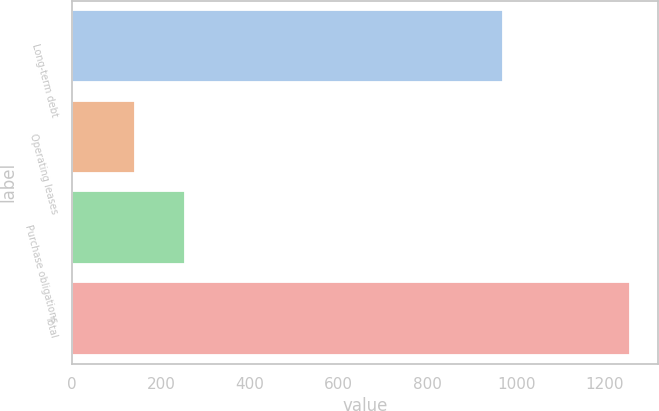Convert chart to OTSL. <chart><loc_0><loc_0><loc_500><loc_500><bar_chart><fcel>Long-term debt<fcel>Operating leases<fcel>Purchase obligations<fcel>Total<nl><fcel>971<fcel>142<fcel>253.5<fcel>1257<nl></chart> 